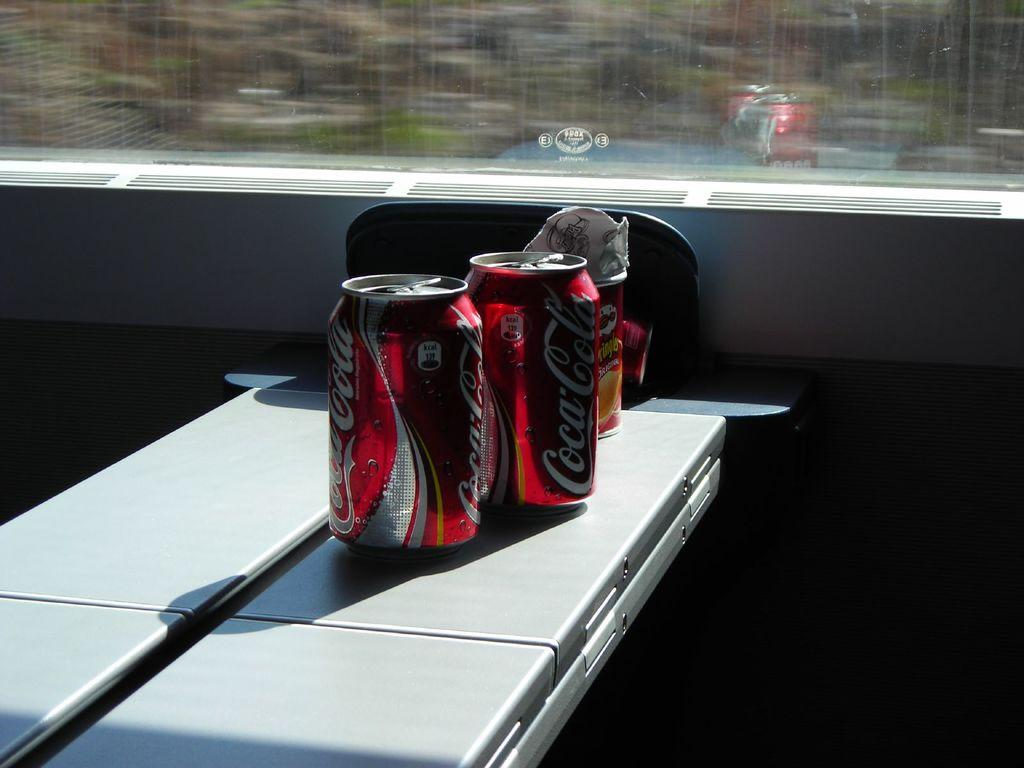What type of product is represented by the tins in the image? There are two Coca-Cola tins in the image. What else can be seen on the table besides the Coca-Cola tins? There are other objects on the table. Where is the table located in relation to the glass window? The table is in front of a glass window. What type of curtain is hanging in front of the glass window in the image? There is no curtain present in the image; it only shows two Coca-Cola tins and other objects on a table in front of a glass window. What religious symbols can be seen in the image? There are no religious symbols present in the image. 